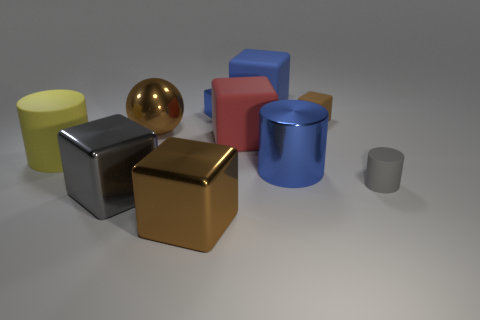Subtract all red blocks. How many blocks are left? 5 Subtract all large brown blocks. How many blocks are left? 5 Subtract all balls. How many objects are left? 9 Subtract all cyan balls. How many blue cylinders are left? 1 Subtract all small brown metal balls. Subtract all large balls. How many objects are left? 9 Add 7 gray matte cylinders. How many gray matte cylinders are left? 8 Add 1 gray shiny things. How many gray shiny things exist? 2 Subtract 0 purple cubes. How many objects are left? 10 Subtract 3 cylinders. How many cylinders are left? 0 Subtract all brown blocks. Subtract all red cylinders. How many blocks are left? 4 